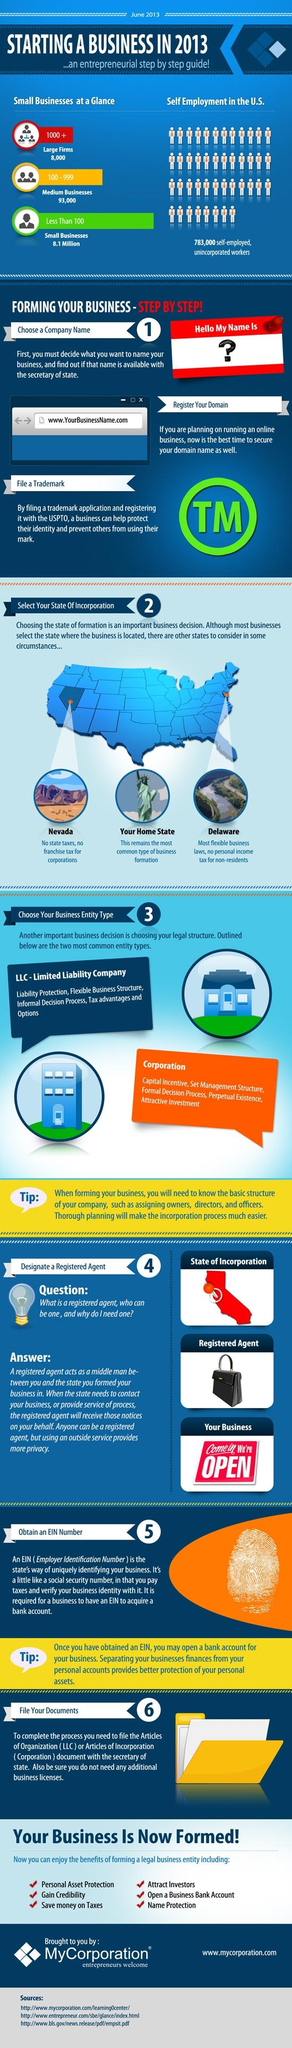List a handful of essential elements in this visual. Nevada is the best location to start a business with zero state taxes. Two of the most common types of business entities are the Limited Liability Company (LLC) and the Corporation. An Employer Identification Number (EIN) is typically used to distinguish one business entity from another. It is more commonly chosen by businesses to register their business address as their home state. To protect the identity of a business, it is crucial to file a trademark application and register it with the USPTO. 